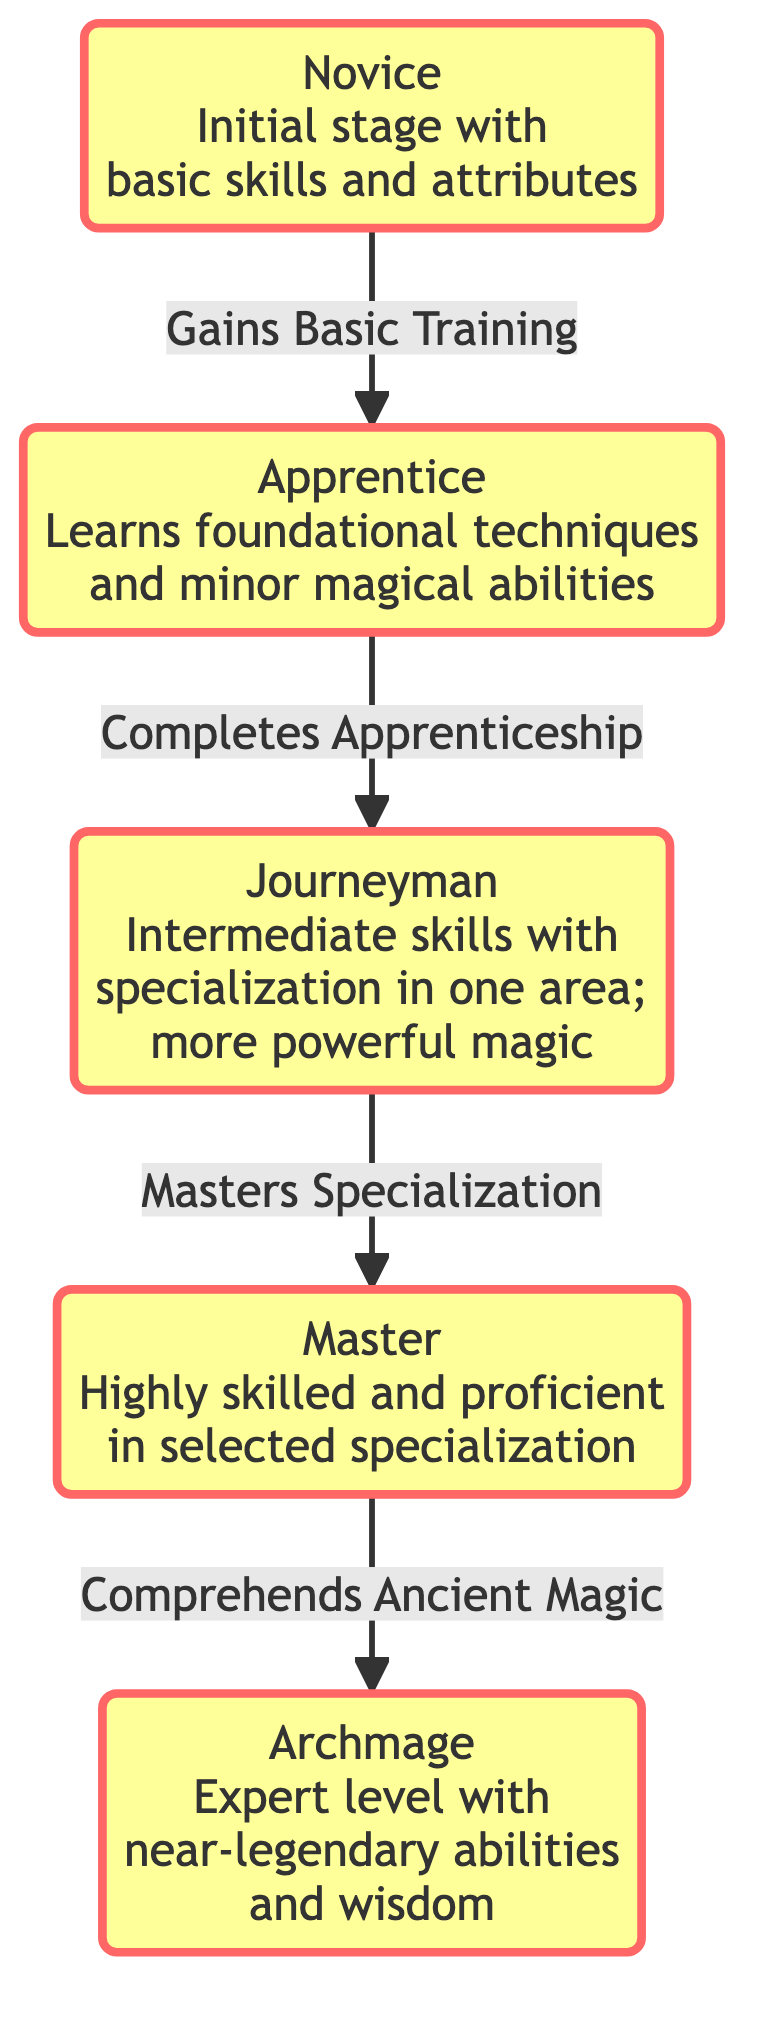What is the initial stage of character evolution? The diagram shows "Novice" as the first node, representing the initial stage with basic skills and attributes.
Answer: Novice How many stages are there in total? The diagram contains five stages: Novice, Apprentice, Journeyman, Master, and Archmage. Counting these nodes gives us a total of 5.
Answer: 5 What does an Apprentice achieve? According to the diagram, an Apprentice learns foundational techniques and minor magical abilities, which is indicated in the description of the related node.
Answer: Foundational techniques What path does a Journeyman follow to become a Master? The arrow connecting Journeyman to Master is labeled with "Masters Specialization," indicating that it is the step taken to evolve to the Master stage.
Answer: Masters Specialization What term describes the highest stage of character evolution? The last node in the diagram is labeled "Archmage," which is identified as the highest stage that represents expert-level skills.
Answer: Archmage How does one become an Archmage from a Master? The transition from the Master stage to the Archmage stage is described as comprehending ancient magic, shown by the label on the connecting arrow.
Answer: Comprehends Ancient Magic Which stage specializes in one area? The diagram highlights "Journeyman" as the stage where the character specializes in one area, as per the node’s description.
Answer: Journeyman What learning process occurs after the Novice stage? The arrow from Novice to Apprentice is labeled "Gains Basic Training," indicating this is the learning process before becoming an Apprentice.
Answer: Gains Basic Training Which stage is characterized by near-legendary abilities? The node marked "Archmage" specifically indicates that it corresponds to near-legendary abilities and wisdom in its description.
Answer: Archmage 